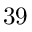Convert formula to latex. <formula><loc_0><loc_0><loc_500><loc_500>3 9</formula> 